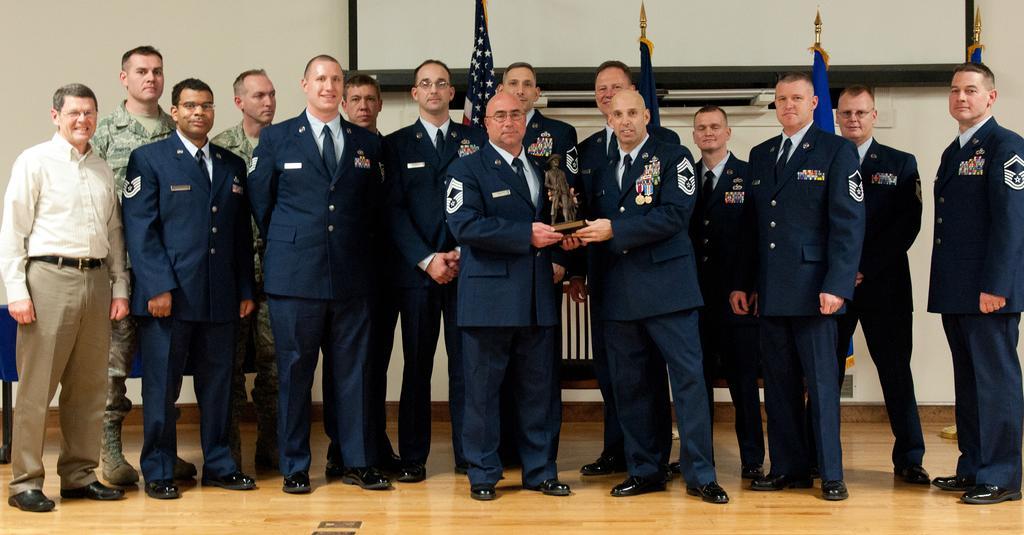Describe this image in one or two sentences. In this picture I can see number of people who are standing in front and I see that these 2 men are holding a thing in their hands. In the background I see the flags and on the wall I see the white color screen and on the bottom of this image I see the floor. 